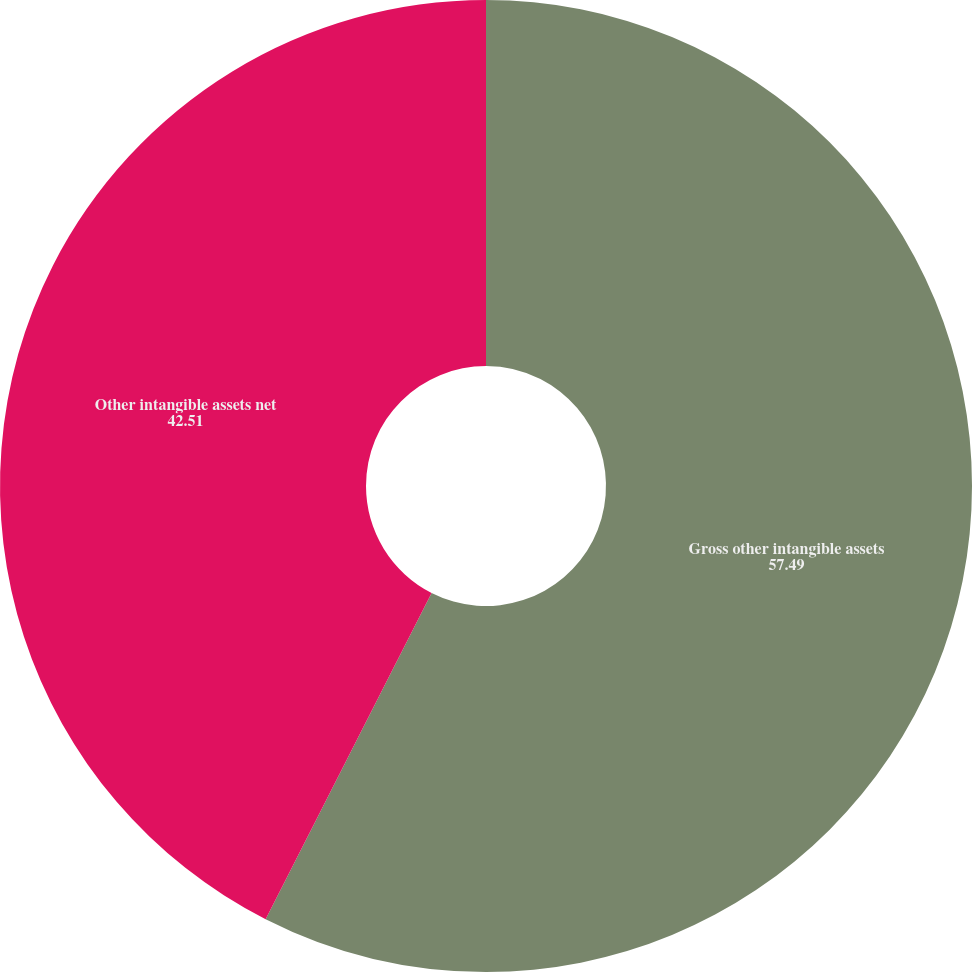Convert chart to OTSL. <chart><loc_0><loc_0><loc_500><loc_500><pie_chart><fcel>Gross other intangible assets<fcel>Other intangible assets net<nl><fcel>57.49%<fcel>42.51%<nl></chart> 